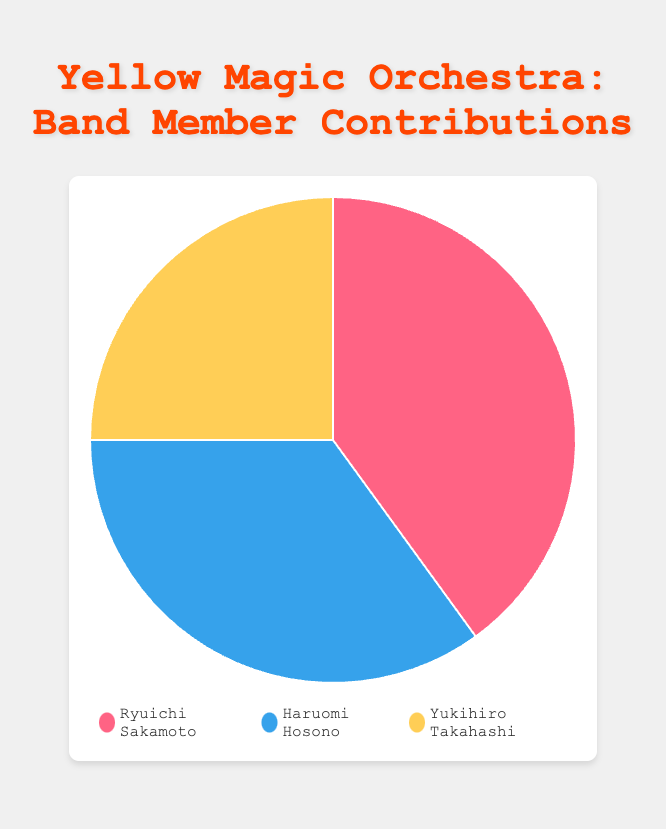Which band member contributed the most to Yellow Magic Orchestra songs? By inspecting the largest segment in the pie chart, Ryuichi Sakamoto's contribution percentage is the highest at 40%.
Answer: Ryuichi Sakamoto Who had the smallest contribution percentage among the band members? By checking the smallest segment in the pie chart, Yukihiro Takahashi had the smallest contribution at 25%.
Answer: Yukihiro Takahashi What is the combined contribution percentage of Ryuichi Sakamoto and Haruomi Hosono? Adding the contributions of Ryuichi Sakamoto (40%) and Haruomi Hosono (35%) gives 40% + 35% = 75%.
Answer: 75% How much more did Ryuichi Sakamoto contribute compared to Yukihiro Takahashi? Subtracting Yukihiro Takahashi's contribution (25%) from Ryuichi Sakamoto's contribution (40%) gives 40% - 25% = 15%.
Answer: 15% What is the difference in contribution percentage between Haruomi Hosono and Yukihiro Takahashi? Subtracting Yukihiro Takahashi's contribution (25%) from Haruomi Hosono's contribution (35%) gives 35% - 25% = 10%.
Answer: 10% Between Haruomi Hosono and Yukihiro Takahashi, who contributed more and by how much? By comparing their contributions, Haruomi Hosono contributed more by a difference of 35% - 25% = 10%.
Answer: Haruomi Hosono by 10% If Ryuichi Sakamoto's contribution was reduced by 5%, how would this compare to Haruomi Hosono’s contribution? Reducing Ryuichi Sakamoto's contribution from 40% to 35% would make it equal to Haruomi Hosono's contribution of 35%.
Answer: Equal Which band member’s contribution percentage is represented by the red color in the pie chart? Referring to the pie chart legend, the red color represents Ryuichi Sakamoto's contribution.
Answer: Ryuichi Sakamoto If the contributions of Haruomi Hosono and Yukihiro Takahashi are combined, do they surpass Ryuichi Sakamoto's contribution? Combining their contributions, Haruomi Hosono (35%) + Yukihiro Takahashi (25%) = 60%, which surpasses Ryuichi Sakamoto's 40%.
Answer: Yes What is the average contribution percentage of the three band members? Adding their contributions gives 40% + 35% + 25% = 100%, divided by 3, the average is 100% / 3 = 33.33%.
Answer: 33.33% 